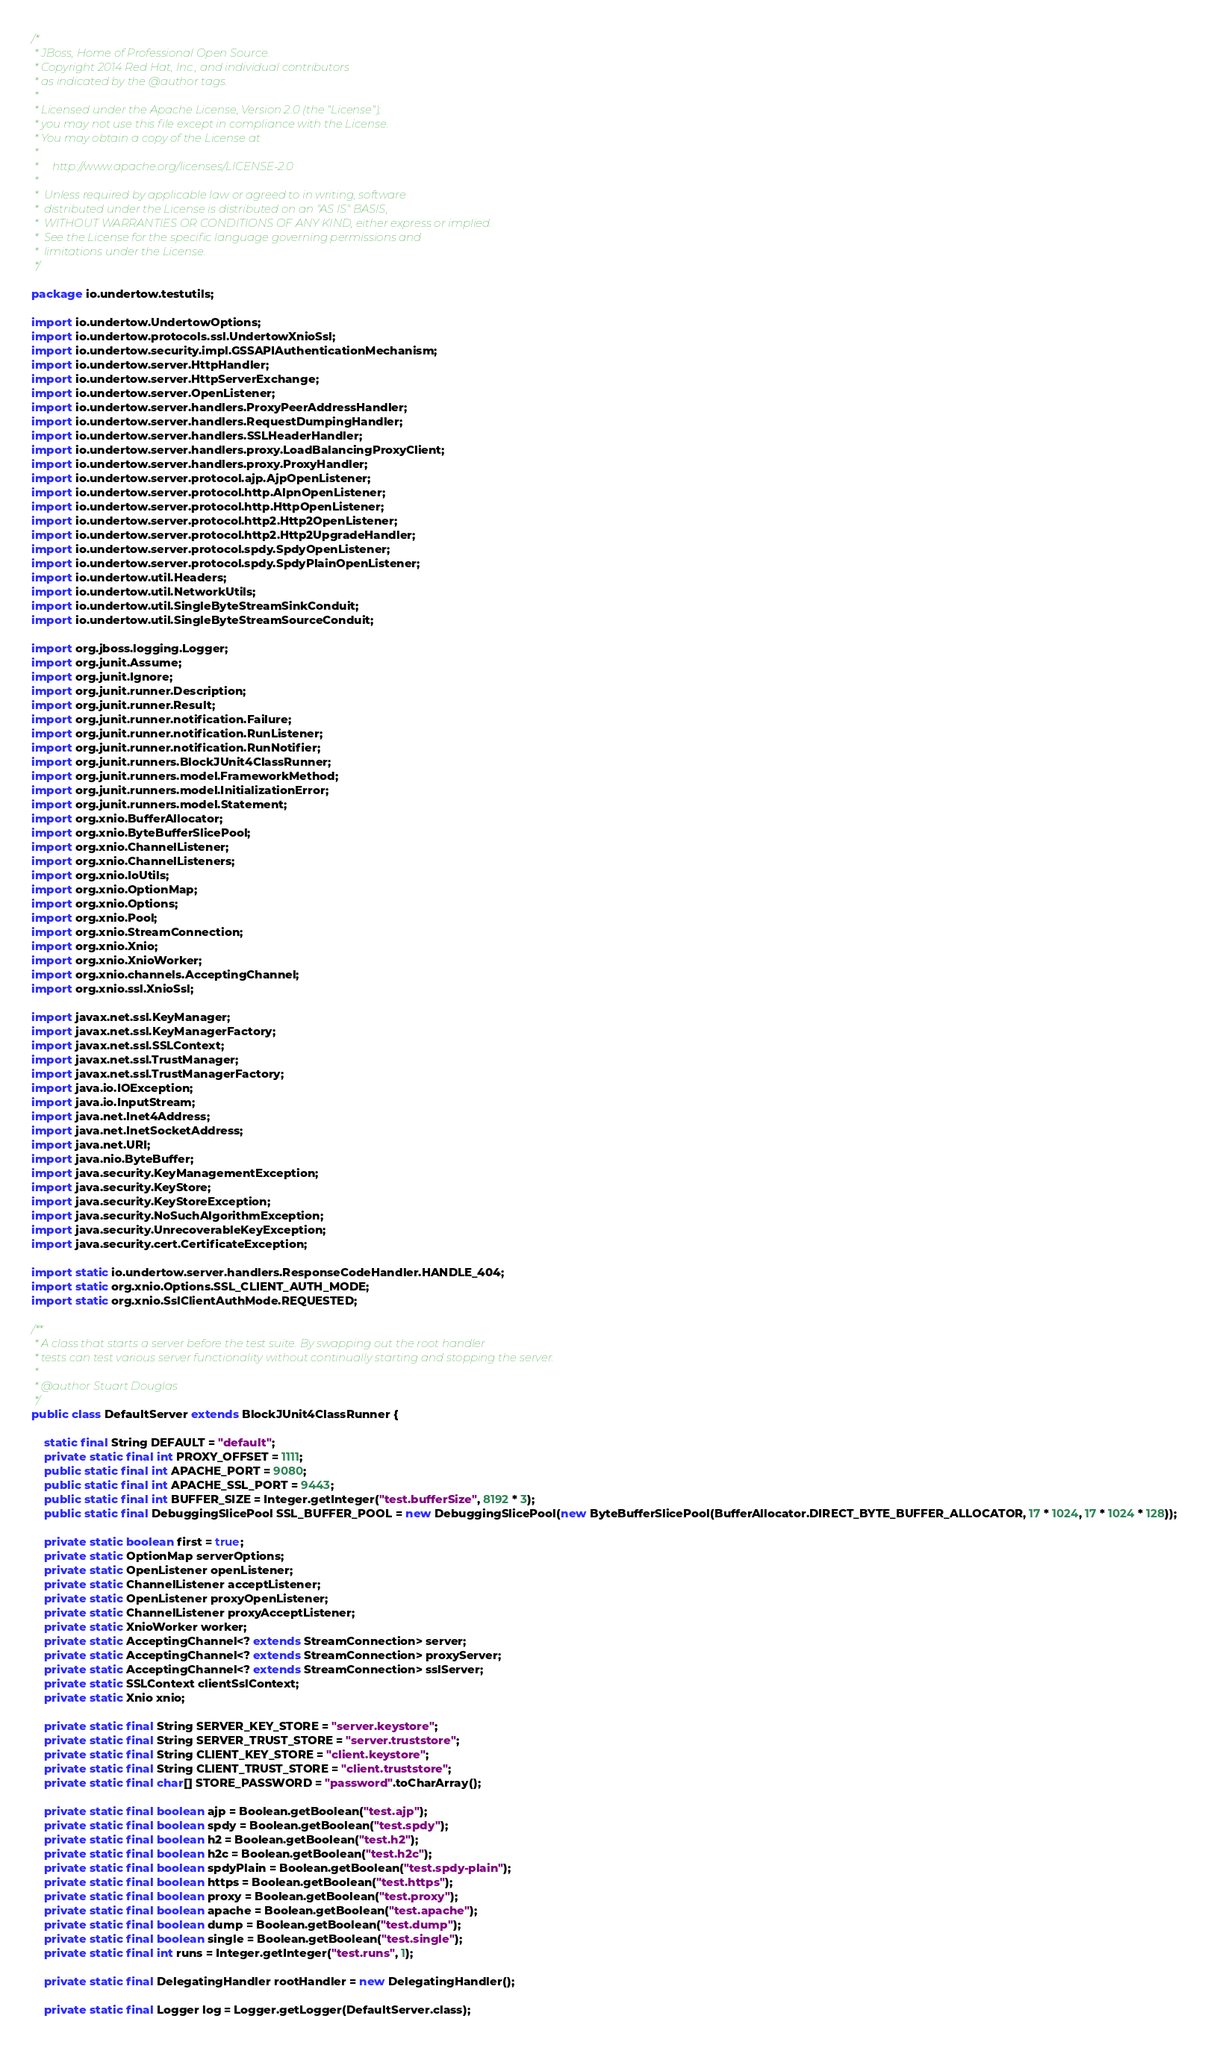<code> <loc_0><loc_0><loc_500><loc_500><_Java_>/*
 * JBoss, Home of Professional Open Source.
 * Copyright 2014 Red Hat, Inc., and individual contributors
 * as indicated by the @author tags.
 *
 * Licensed under the Apache License, Version 2.0 (the "License");
 * you may not use this file except in compliance with the License.
 * You may obtain a copy of the License at
 *
 *     http://www.apache.org/licenses/LICENSE-2.0
 *
 *  Unless required by applicable law or agreed to in writing, software
 *  distributed under the License is distributed on an "AS IS" BASIS,
 *  WITHOUT WARRANTIES OR CONDITIONS OF ANY KIND, either express or implied.
 *  See the License for the specific language governing permissions and
 *  limitations under the License.
 */

package io.undertow.testutils;

import io.undertow.UndertowOptions;
import io.undertow.protocols.ssl.UndertowXnioSsl;
import io.undertow.security.impl.GSSAPIAuthenticationMechanism;
import io.undertow.server.HttpHandler;
import io.undertow.server.HttpServerExchange;
import io.undertow.server.OpenListener;
import io.undertow.server.handlers.ProxyPeerAddressHandler;
import io.undertow.server.handlers.RequestDumpingHandler;
import io.undertow.server.handlers.SSLHeaderHandler;
import io.undertow.server.handlers.proxy.LoadBalancingProxyClient;
import io.undertow.server.handlers.proxy.ProxyHandler;
import io.undertow.server.protocol.ajp.AjpOpenListener;
import io.undertow.server.protocol.http.AlpnOpenListener;
import io.undertow.server.protocol.http.HttpOpenListener;
import io.undertow.server.protocol.http2.Http2OpenListener;
import io.undertow.server.protocol.http2.Http2UpgradeHandler;
import io.undertow.server.protocol.spdy.SpdyOpenListener;
import io.undertow.server.protocol.spdy.SpdyPlainOpenListener;
import io.undertow.util.Headers;
import io.undertow.util.NetworkUtils;
import io.undertow.util.SingleByteStreamSinkConduit;
import io.undertow.util.SingleByteStreamSourceConduit;

import org.jboss.logging.Logger;
import org.junit.Assume;
import org.junit.Ignore;
import org.junit.runner.Description;
import org.junit.runner.Result;
import org.junit.runner.notification.Failure;
import org.junit.runner.notification.RunListener;
import org.junit.runner.notification.RunNotifier;
import org.junit.runners.BlockJUnit4ClassRunner;
import org.junit.runners.model.FrameworkMethod;
import org.junit.runners.model.InitializationError;
import org.junit.runners.model.Statement;
import org.xnio.BufferAllocator;
import org.xnio.ByteBufferSlicePool;
import org.xnio.ChannelListener;
import org.xnio.ChannelListeners;
import org.xnio.IoUtils;
import org.xnio.OptionMap;
import org.xnio.Options;
import org.xnio.Pool;
import org.xnio.StreamConnection;
import org.xnio.Xnio;
import org.xnio.XnioWorker;
import org.xnio.channels.AcceptingChannel;
import org.xnio.ssl.XnioSsl;

import javax.net.ssl.KeyManager;
import javax.net.ssl.KeyManagerFactory;
import javax.net.ssl.SSLContext;
import javax.net.ssl.TrustManager;
import javax.net.ssl.TrustManagerFactory;
import java.io.IOException;
import java.io.InputStream;
import java.net.Inet4Address;
import java.net.InetSocketAddress;
import java.net.URI;
import java.nio.ByteBuffer;
import java.security.KeyManagementException;
import java.security.KeyStore;
import java.security.KeyStoreException;
import java.security.NoSuchAlgorithmException;
import java.security.UnrecoverableKeyException;
import java.security.cert.CertificateException;

import static io.undertow.server.handlers.ResponseCodeHandler.HANDLE_404;
import static org.xnio.Options.SSL_CLIENT_AUTH_MODE;
import static org.xnio.SslClientAuthMode.REQUESTED;

/**
 * A class that starts a server before the test suite. By swapping out the root handler
 * tests can test various server functionality without continually starting and stopping the server.
 *
 * @author Stuart Douglas
 */
public class DefaultServer extends BlockJUnit4ClassRunner {

    static final String DEFAULT = "default";
    private static final int PROXY_OFFSET = 1111;
    public static final int APACHE_PORT = 9080;
    public static final int APACHE_SSL_PORT = 9443;
    public static final int BUFFER_SIZE = Integer.getInteger("test.bufferSize", 8192 * 3);
    public static final DebuggingSlicePool SSL_BUFFER_POOL = new DebuggingSlicePool(new ByteBufferSlicePool(BufferAllocator.DIRECT_BYTE_BUFFER_ALLOCATOR, 17 * 1024, 17 * 1024 * 128));

    private static boolean first = true;
    private static OptionMap serverOptions;
    private static OpenListener openListener;
    private static ChannelListener acceptListener;
    private static OpenListener proxyOpenListener;
    private static ChannelListener proxyAcceptListener;
    private static XnioWorker worker;
    private static AcceptingChannel<? extends StreamConnection> server;
    private static AcceptingChannel<? extends StreamConnection> proxyServer;
    private static AcceptingChannel<? extends StreamConnection> sslServer;
    private static SSLContext clientSslContext;
    private static Xnio xnio;

    private static final String SERVER_KEY_STORE = "server.keystore";
    private static final String SERVER_TRUST_STORE = "server.truststore";
    private static final String CLIENT_KEY_STORE = "client.keystore";
    private static final String CLIENT_TRUST_STORE = "client.truststore";
    private static final char[] STORE_PASSWORD = "password".toCharArray();

    private static final boolean ajp = Boolean.getBoolean("test.ajp");
    private static final boolean spdy = Boolean.getBoolean("test.spdy");
    private static final boolean h2 = Boolean.getBoolean("test.h2");
    private static final boolean h2c = Boolean.getBoolean("test.h2c");
    private static final boolean spdyPlain = Boolean.getBoolean("test.spdy-plain");
    private static final boolean https = Boolean.getBoolean("test.https");
    private static final boolean proxy = Boolean.getBoolean("test.proxy");
    private static final boolean apache = Boolean.getBoolean("test.apache");
    private static final boolean dump = Boolean.getBoolean("test.dump");
    private static final boolean single = Boolean.getBoolean("test.single");
    private static final int runs = Integer.getInteger("test.runs", 1);

    private static final DelegatingHandler rootHandler = new DelegatingHandler();

    private static final Logger log = Logger.getLogger(DefaultServer.class);
</code> 